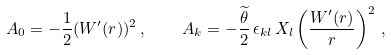Convert formula to latex. <formula><loc_0><loc_0><loc_500><loc_500>A _ { 0 } = - \frac { 1 } { 2 } ( W ^ { \prime } ( r ) ) ^ { 2 } \, , \quad A _ { k } = - \frac { \widetilde { \theta } } { 2 } \, \epsilon _ { k l } \, X _ { l } \left ( \frac { W ^ { \prime } ( r ) } { r } \right ) ^ { 2 } \, ,</formula> 